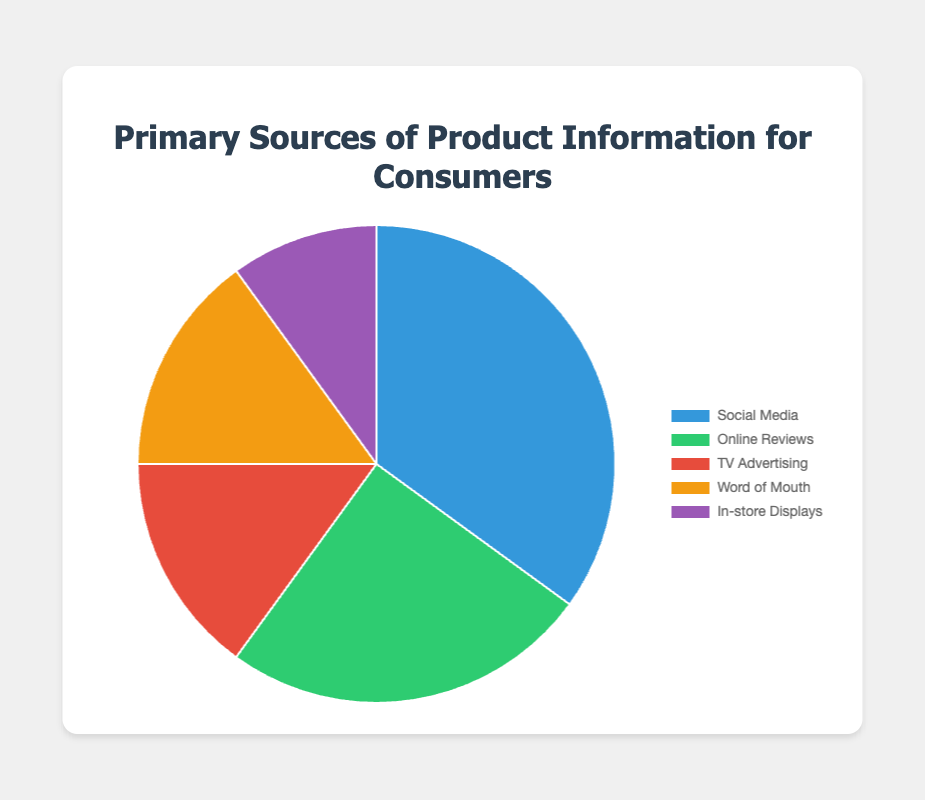What source of product information accounts for the largest percentage? Social Media has the highest percentage among the sources, accounting for 35%. You can see this from the size of the pie slice for Social Media which is the largest.
Answer: Social Media What is the combined percentage for TV Advertising and Word of Mouth? Both TV Advertising and Word of Mouth each have a percentage of 15%. Combining them, the total is 15% + 15% = 30%.
Answer: 30% Between Online Reviews and In-store Displays, which source has more influence and by how much? Online Reviews have a higher percentage compared to In-store Displays. The percentages are 25% for Online Reviews and 10% for In-store Displays, so Online Reviews have a higher influence by 25% - 10% = 15%.
Answer: Online Reviews by 15% Rank the sources of product information from highest to lowest influence. Sort the sources based on their percentages: Social Media (35%), Online Reviews (25%), TV Advertising (15%), Word of Mouth (15%), In-store Displays (10%). So, the ranking from highest to lowest influence is: Social Media, Online Reviews, TV Advertising & Word of Mouth (tie), In-store Displays.
Answer: Social Media, Online Reviews, TV Advertising & Word of Mouth, In-store Displays What is the difference in percentage between the least influential and most influential sources? The least influential source is In-store Displays with 10%, and the most influential source is Social Media with 35%. The difference is 35% - 10% = 25%.
Answer: 25% Which sources have the same level of influence according to the pie chart? TV Advertising and Word of Mouth both account for 15% of the sources of product information, indicating they have the same level of influence.
Answer: TV Advertising and Word of Mouth What is the total percentage covered by all the sources listed in the pie chart? Add up the percentages of all the sources: 35% (Social Media) + 25% (Online Reviews) + 15% (TV Advertising) + 15% (Word of Mouth) + 10% (In-store Displays) = 100%. The total should cover 100% as it represents the entire pie chart.
Answer: 100% 